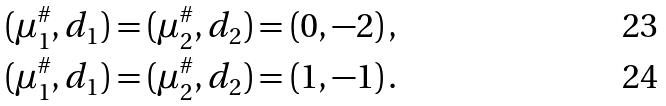Convert formula to latex. <formula><loc_0><loc_0><loc_500><loc_500>( \mu _ { 1 } ^ { \# } , d _ { 1 } ) = ( \mu _ { 2 } ^ { \# } , d _ { 2 } ) & = ( 0 , - 2 ) \, , \\ ( \mu _ { 1 } ^ { \# } , d _ { 1 } ) = ( \mu _ { 2 } ^ { \# } , d _ { 2 } ) & = ( 1 , - 1 ) \, .</formula> 